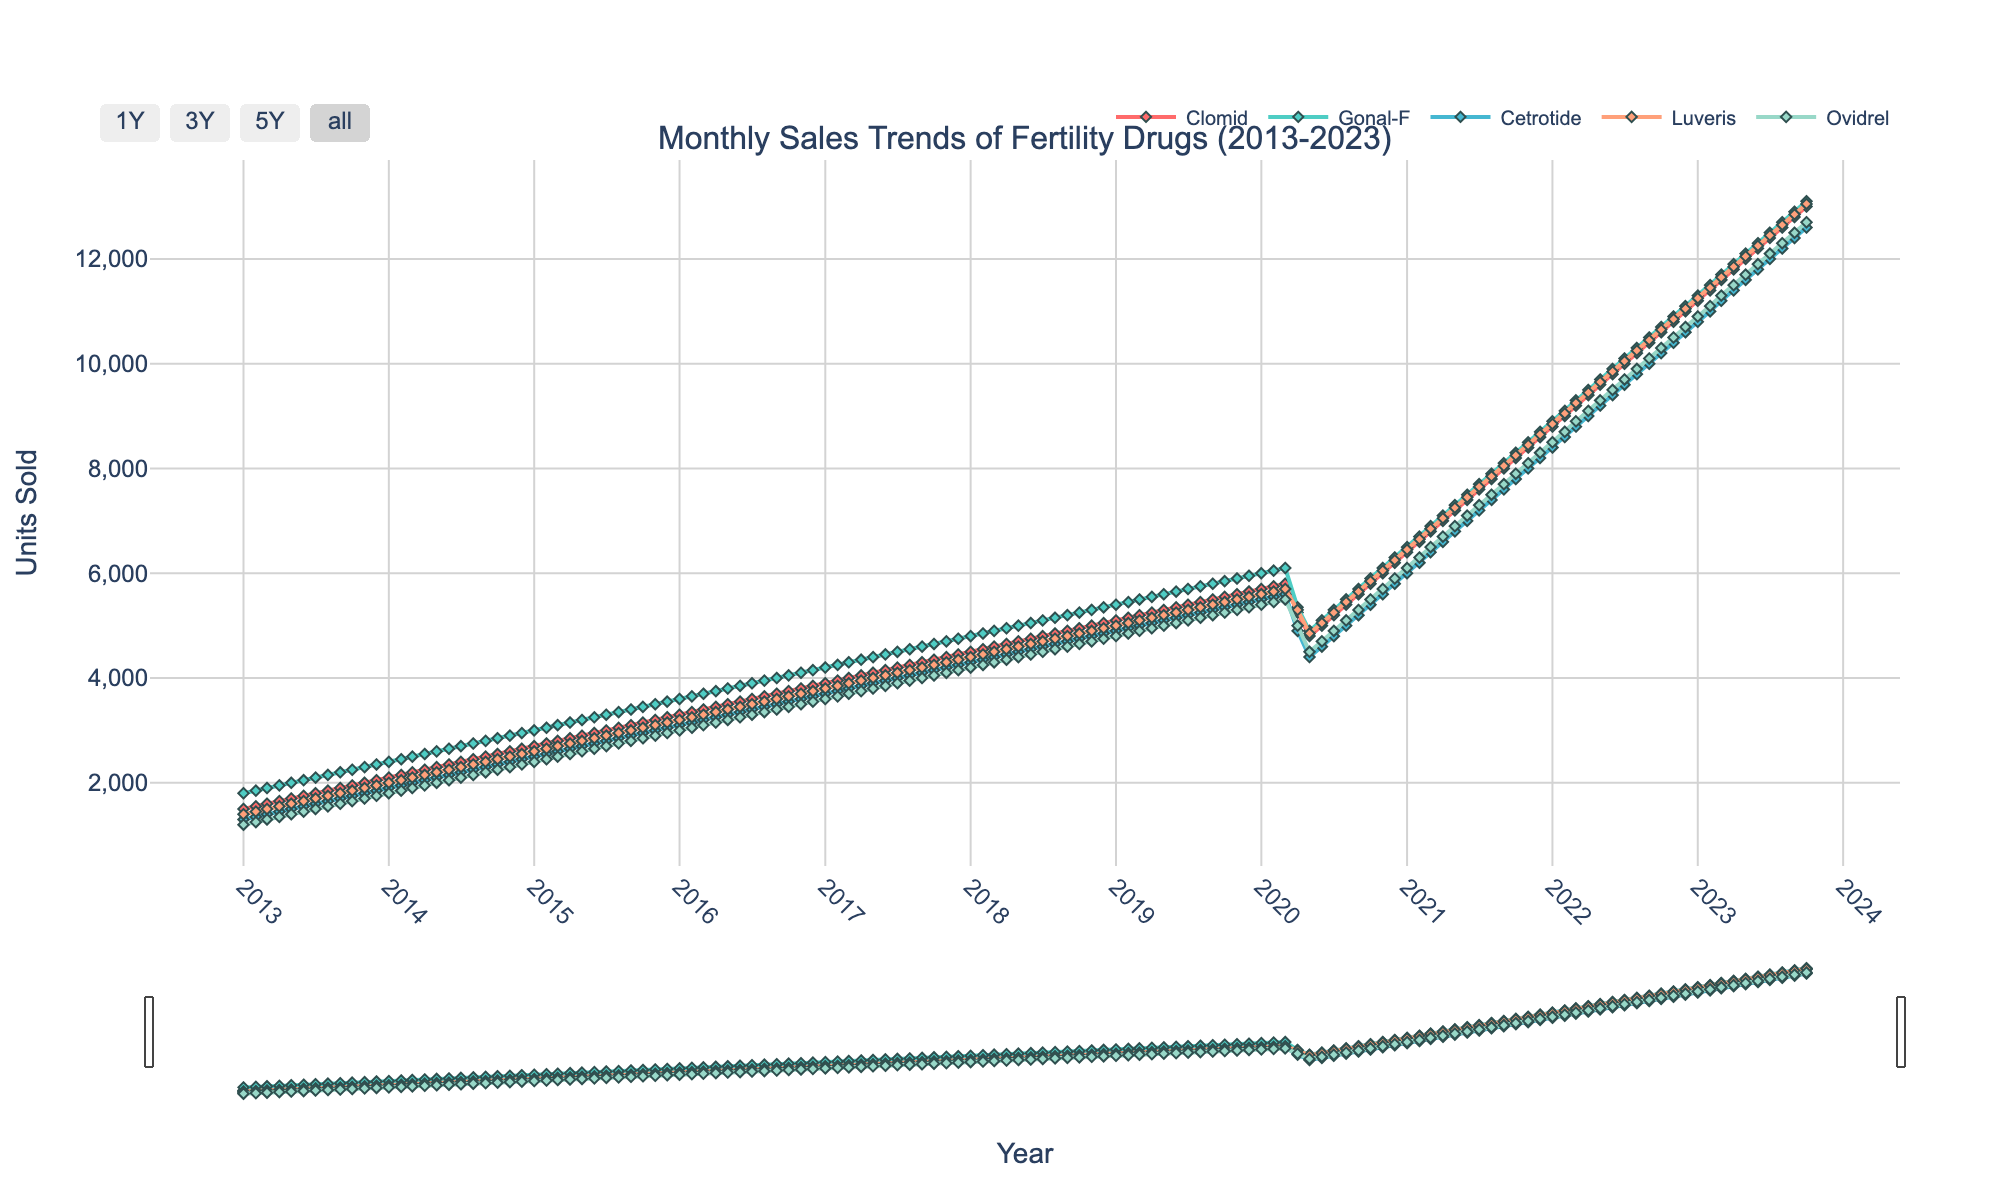What is the title of the figure? The title of the figure is displayed at the top and summarizes the content of the plot.
Answer: Monthly Sales Trends of Fertility Drugs (2013-2023) What year marks the highest point of sales for Clomid? Locate the peak of Clomid's line in the plot and identify the corresponding year along the x-axis.
Answer: 2023 Between which years did Gonal-F experience the most rapid increase in units sold? Examine the slope of Gonal-F's line and identify the steepest segment, then check the corresponding years on the x-axis.
Answer: 2020 to 2021 How do the sales trends of Cetrotide and Luveris compare in the year 2020? Refer to the plot and compare the units sold for Cetrotide and Luveris at different months in 2020.
Answer: Luveris's sales dipped earlier in 2020 compared to Cetrotide What is the total sales units of Ovidrel in 2015? Sum the units sold for Ovidrel in each month of 2015 from the plot. January: 2400, February: 2450, March: 2500, ..., December: 2950. (Sum: 34450)
Answer: 34450 Which drug had the least variation in sales over the decade? Observe the consistency of each drug's line. The drug with the flattest line has the least variation.
Answer: Luveris During which year did the sales of Clomid first surpass 7000 units? Follow Clomid’s line and identify the x-axis tick where the sales first exceed 7000 units.
Answer: 2021 How did sales of all drugs behave at the peak pandemic year of 2020? Check the plot for the sales units of each drug during 2020 and note the general trends (increase, decrease, or stable).
Answer: Initial decrease with subsequent recovery What was the approximate difference in sales units between Clomid and Gonal-F in July 2022? Look at the plot data points for Clomid and Gonal-F in July 2022, then calculate the difference between the two values. Clomid: 10000 units, Gonal-F: 10100 units. (Difference: 100)
Answer: 100 Which drug shows the highest increase in units sold from January 2013 to October 2023? Compare the increase in units sold for each drug by looking at the starting and ending points of their lines on the plot.
Answer: Clomid 